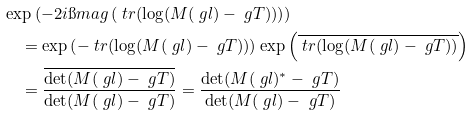Convert formula to latex. <formula><loc_0><loc_0><loc_500><loc_500>& \exp \left ( - 2 i \i m a g \left ( \ t r ( \log ( M ( \ g l ) - \ g T ) ) \right ) \right ) \\ & \quad = \exp \left ( - \ t r ( \log ( M ( \ g l ) - \ g T ) ) \right ) \exp \left ( \overline { \ t r ( \log ( M ( \ g l ) - \ g T ) ) } \right ) \\ & \quad = \frac { \overline { \det ( M ( \ g l ) - \ g T ) } } { \det ( M ( \ g l ) - \ g T ) } = \frac { \det ( M ( \ g l ) ^ { * } - \ g T ) } { \det ( M ( \ g l ) - \ g T ) }</formula> 